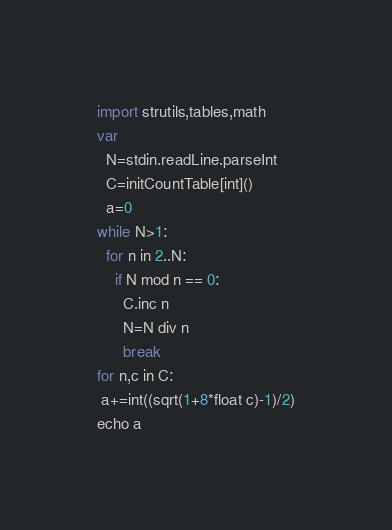<code> <loc_0><loc_0><loc_500><loc_500><_Nim_>import strutils,tables,math
var
  N=stdin.readLine.parseInt
  C=initCountTable[int]()
  a=0
while N>1:
  for n in 2..N:
    if N mod n == 0:
      C.inc n
      N=N div n
      break
for n,c in C:
 a+=int((sqrt(1+8*float c)-1)/2)
echo a</code> 